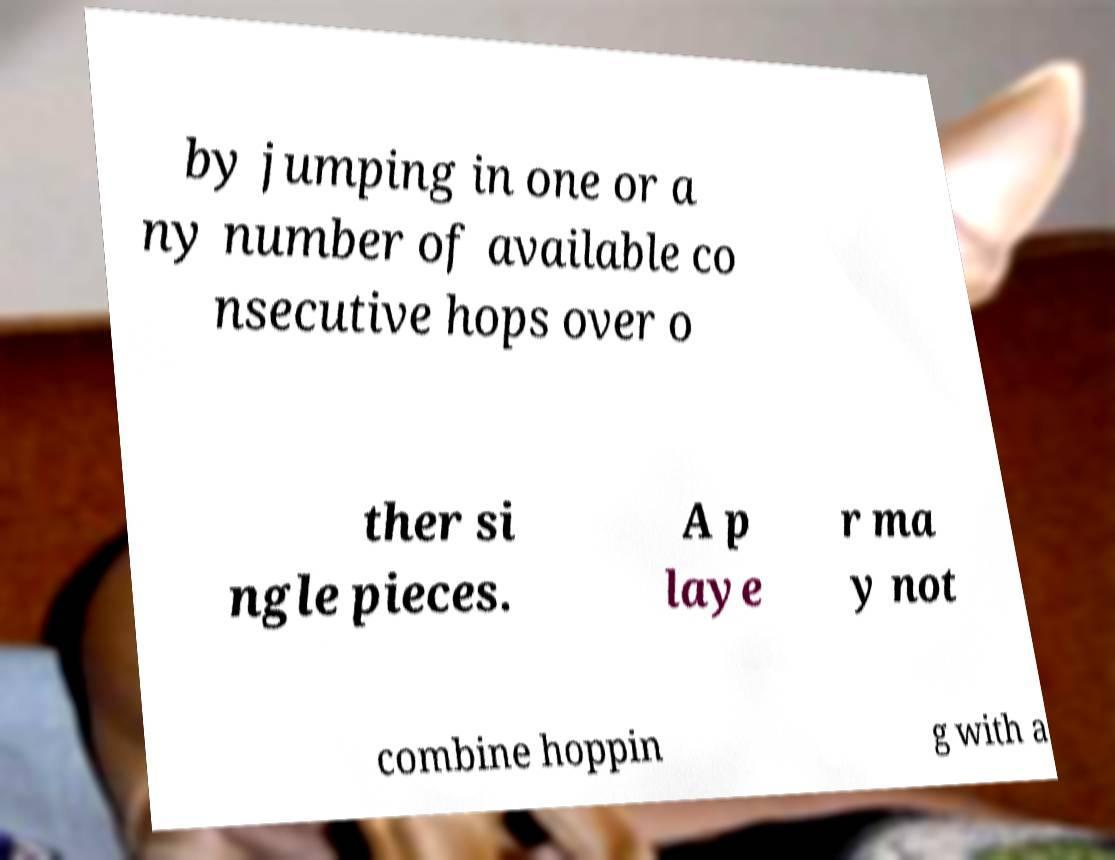Please read and relay the text visible in this image. What does it say? by jumping in one or a ny number of available co nsecutive hops over o ther si ngle pieces. A p laye r ma y not combine hoppin g with a 